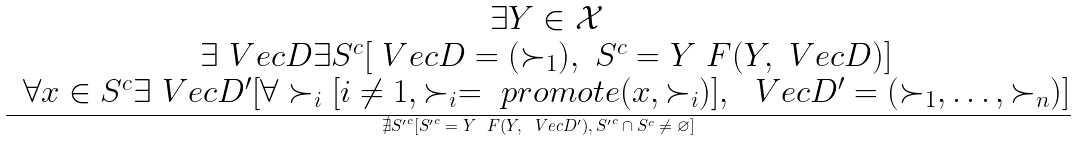Convert formula to latex. <formula><loc_0><loc_0><loc_500><loc_500>\frac { \begin{matrix} & \exists Y \in \mathcal { X } \\ & \exists \ V e c { D } \exists S ^ { c } [ \ V e c { D } = ( \succ _ { 1 } ) , \ S ^ { c } = Y \ F ( Y , \ V e c { D } ) ] \\ & \forall x \in S ^ { c } \exists \ V e c { D } ^ { \prime } [ \forall \succ _ { i } [ i \ne 1 , \succ _ { i } = \ p r o m o t e ( x , \succ _ { i } ) ] , \ \ V e c { D } ^ { \prime } = ( \succ _ { 1 } , \dots , \succ _ { n } ) ] \end{matrix} } { \nexists { S ^ { \prime } } ^ { c } [ { S ^ { \prime } } ^ { c } = Y \ F ( Y , \ V e c { D } ^ { \prime } ) , { S ^ { \prime } } ^ { c } \cap S ^ { c } \ne \varnothing ] }</formula> 